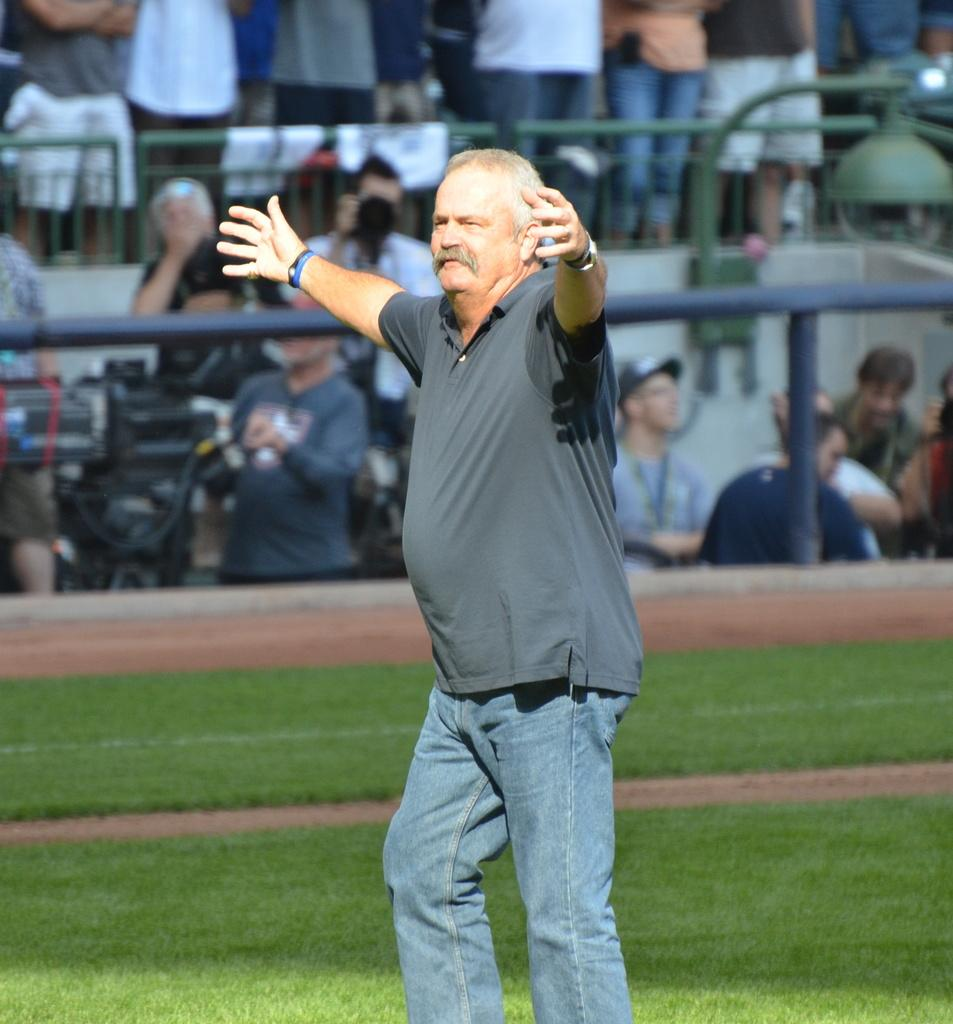What is the person in the image wearing on their wrist? The person is wearing a wristband in the image. What is the person's posture in the image? The person is standing in the image. What type of surface is under the person's feet? There is a grass lawn on the ground in the image. How many people are visible in the background of the image? There are many people in the background of the image. What architectural features can be seen in the background? Railings and rods are present in the background of the image. What type of basin is visible in the image? There is no basin present in the image. What noise can be heard coming from the person in the image? The image is silent, so no noise can be heard. 